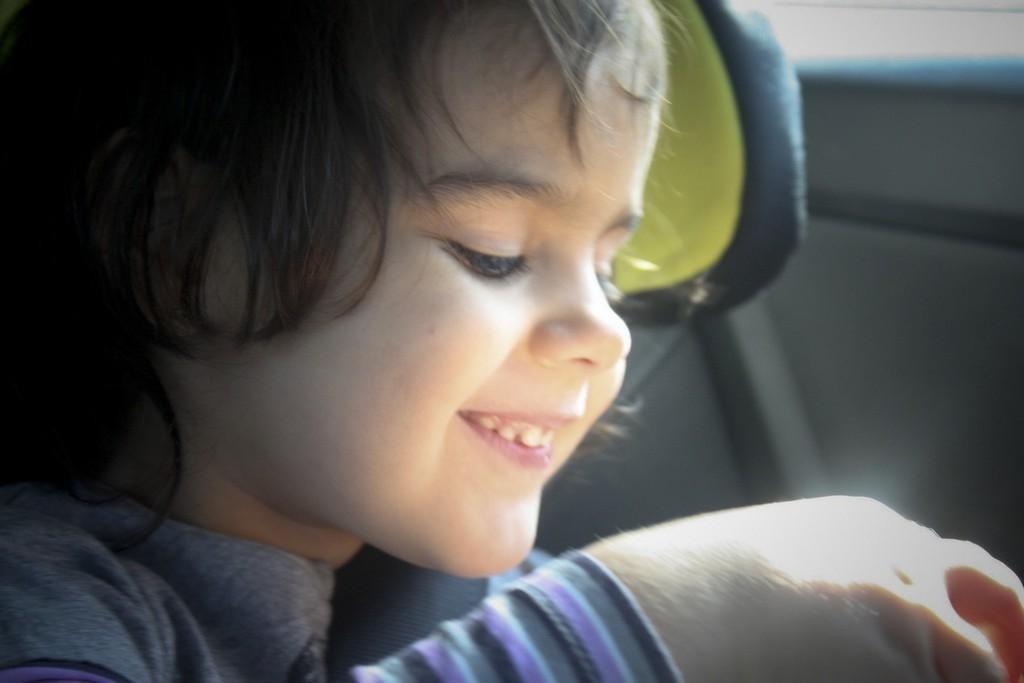Can you describe this image briefly? In this image we can see a kid smiling and in the background, we can see an object. 